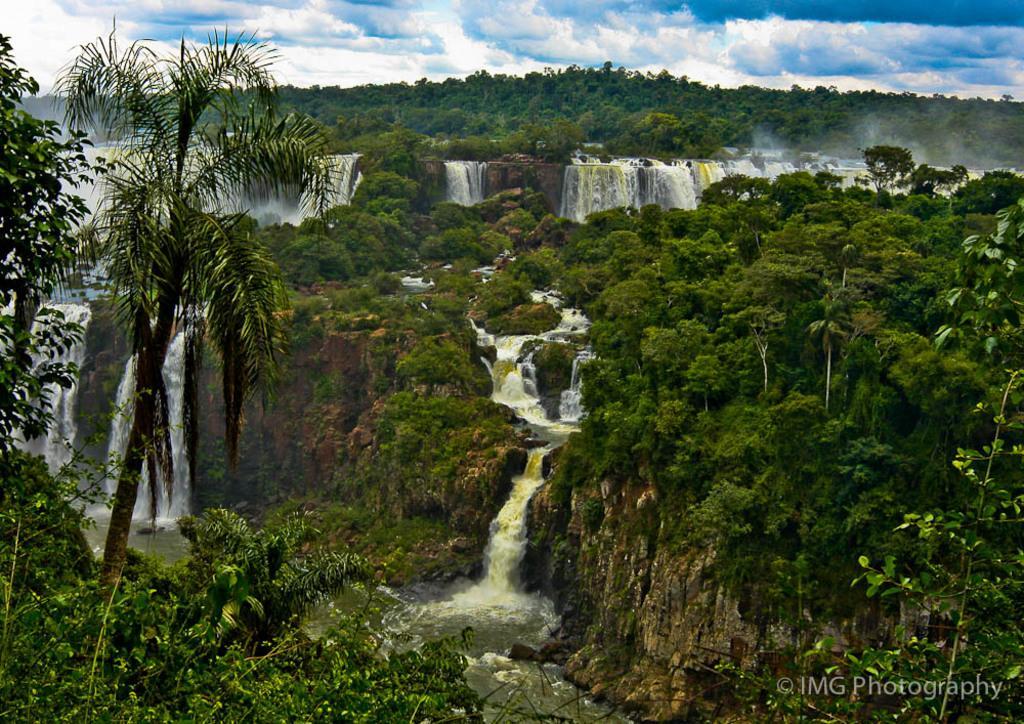How would you summarize this image in a sentence or two? In this picture we can see trees, water and clouds, at the right bottom of the image we can see a watermark. 